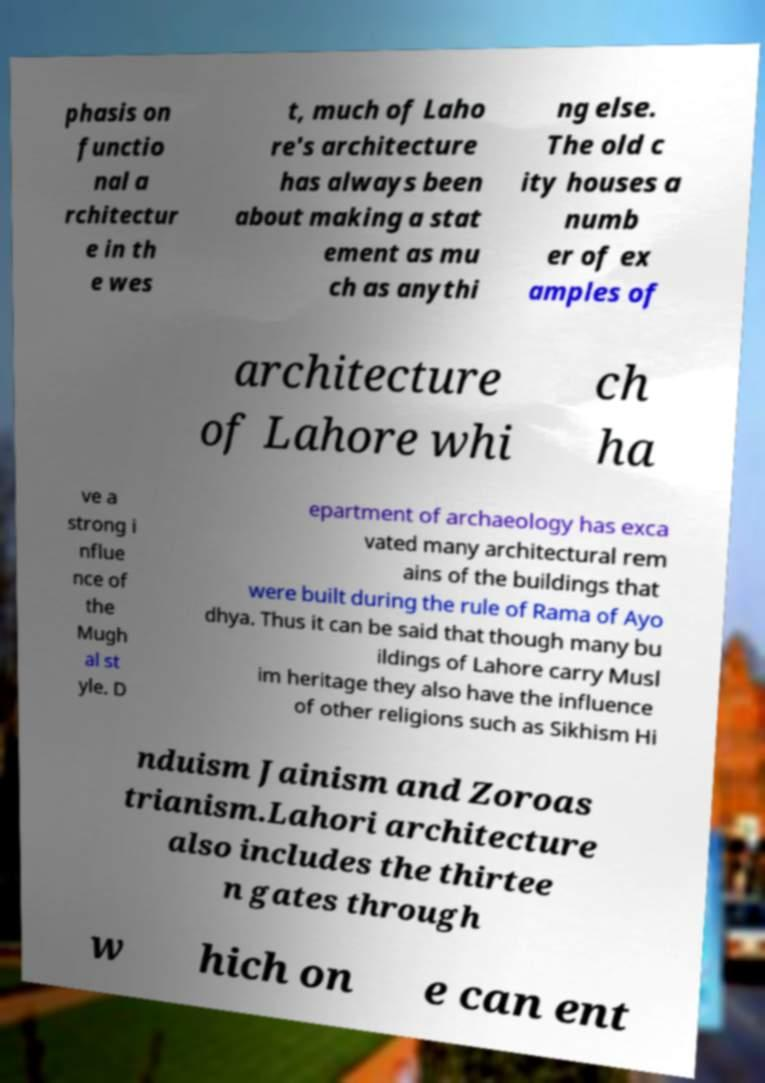What messages or text are displayed in this image? I need them in a readable, typed format. phasis on functio nal a rchitectur e in th e wes t, much of Laho re's architecture has always been about making a stat ement as mu ch as anythi ng else. The old c ity houses a numb er of ex amples of architecture of Lahore whi ch ha ve a strong i nflue nce of the Mugh al st yle. D epartment of archaeology has exca vated many architectural rem ains of the buildings that were built during the rule of Rama of Ayo dhya. Thus it can be said that though many bu ildings of Lahore carry Musl im heritage they also have the influence of other religions such as Sikhism Hi nduism Jainism and Zoroas trianism.Lahori architecture also includes the thirtee n gates through w hich on e can ent 